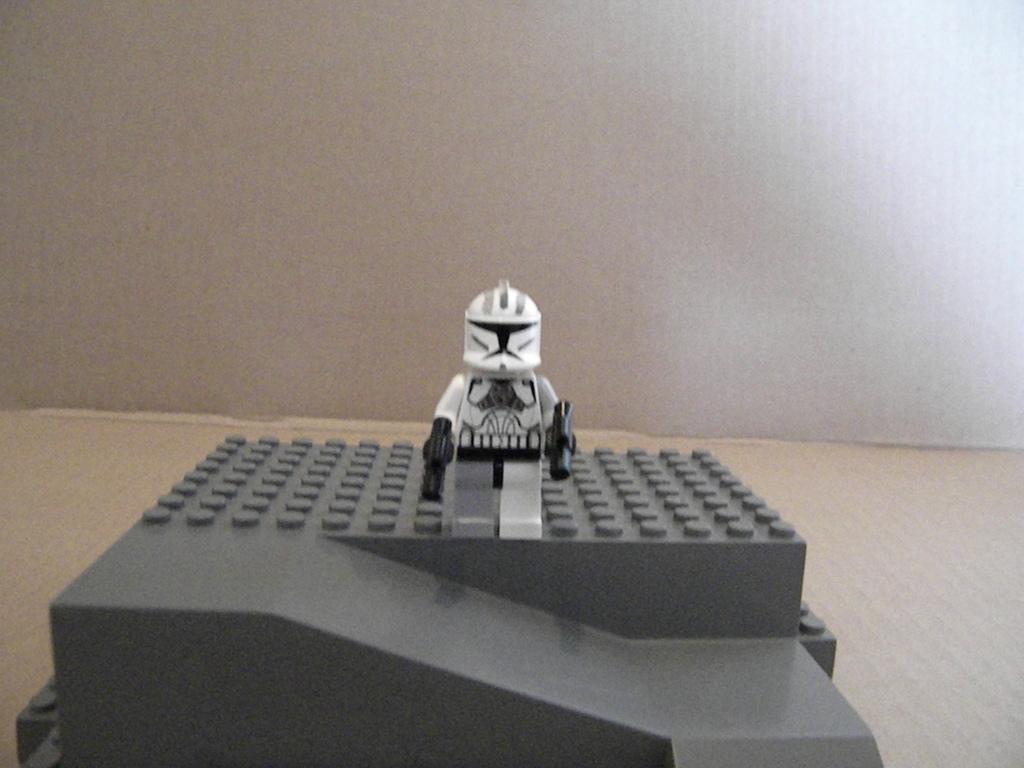How would you summarize this image in a sentence or two? In this image there is a gadget and a toy, in the background there is a wall. 